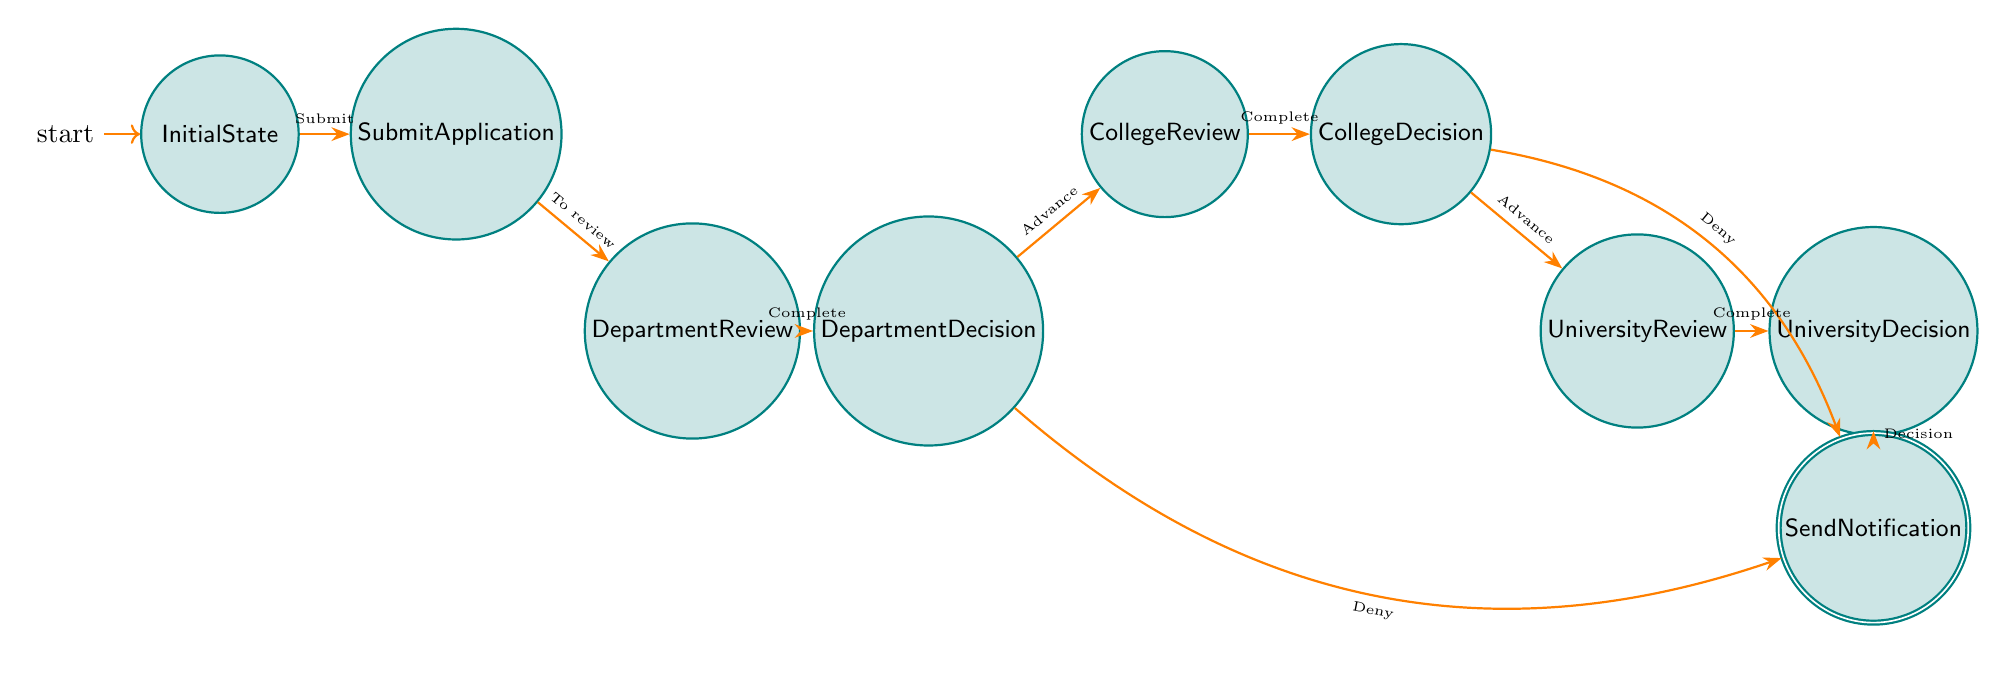What is the initial state of the tenure review process? The diagram indicates that the process starts at the "InitialState" node, which is the first point in the tenure review process.
Answer: InitialState How many decision points are there in the process? The diagram shows three decision points: "DepartmentDecision," "CollegeDecision," and "UniversityDecision," where decisions about advancing the application are evaluated.
Answer: Three What happens after the "DepartmentDecision" if the application is denied? The diagram states that if the application is denied at the "DepartmentDecision" node, the process transitions directly to the "SendNotification" node to inform the faculty member.
Answer: SendNotification What are the final nodes of the tenure review process? The diagram highlights that the final node after all reviews and decisions is "SendNotification," which is where the faculty member is informed of the decision.
Answer: SendNotification What is the sequence of states from application submission to the university decision? The sequence involves moving from "SubmitApplication" to "DepartmentReview," then to "DepartmentDecision," followed by "CollegeReview," "CollegeDecision," "UniversityReview," and finally to "UniversityDecision."
Answer: SubmitApplication, DepartmentReview, DepartmentDecision, CollegeReview, CollegeDecision, UniversityReview, UniversityDecision What is required for the application to move from "CollegeDecision" to "UniversityReview"? The diagram specifies that the application must be advanced by the "CollegeDecision" for it to move to the next state, which is "UniversityReview."
Answer: Advance Which nodes are reached if the application is denied at both "DepartmentDecision" and "CollegeDecision"? Based on the diagram, if the application is denied at either the "DepartmentDecision" or "CollegeDecision," it leads to the "SendNotification" node which is the end of the process for denied applications.
Answer: SendNotification At which state does the application move after the "UniversityReview"? The diagram indicates that after the "UniversityReview" is completed, the application moves to the "UniversityDecision" state, where the final decision is made.
Answer: UniversityDecision 